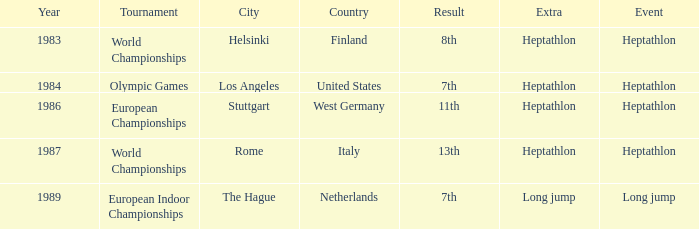Where was the 1984 Olympics hosted? Olympic Games. 